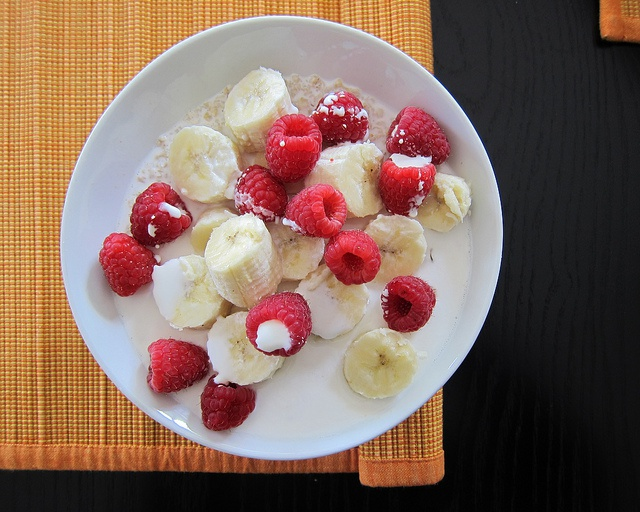Describe the objects in this image and their specific colors. I can see dining table in tan, black, brown, and navy tones, banana in tan, lightgray, darkgray, and beige tones, banana in tan, beige, and lightgray tones, banana in tan, lightgray, and brown tones, and banana in tan and beige tones in this image. 